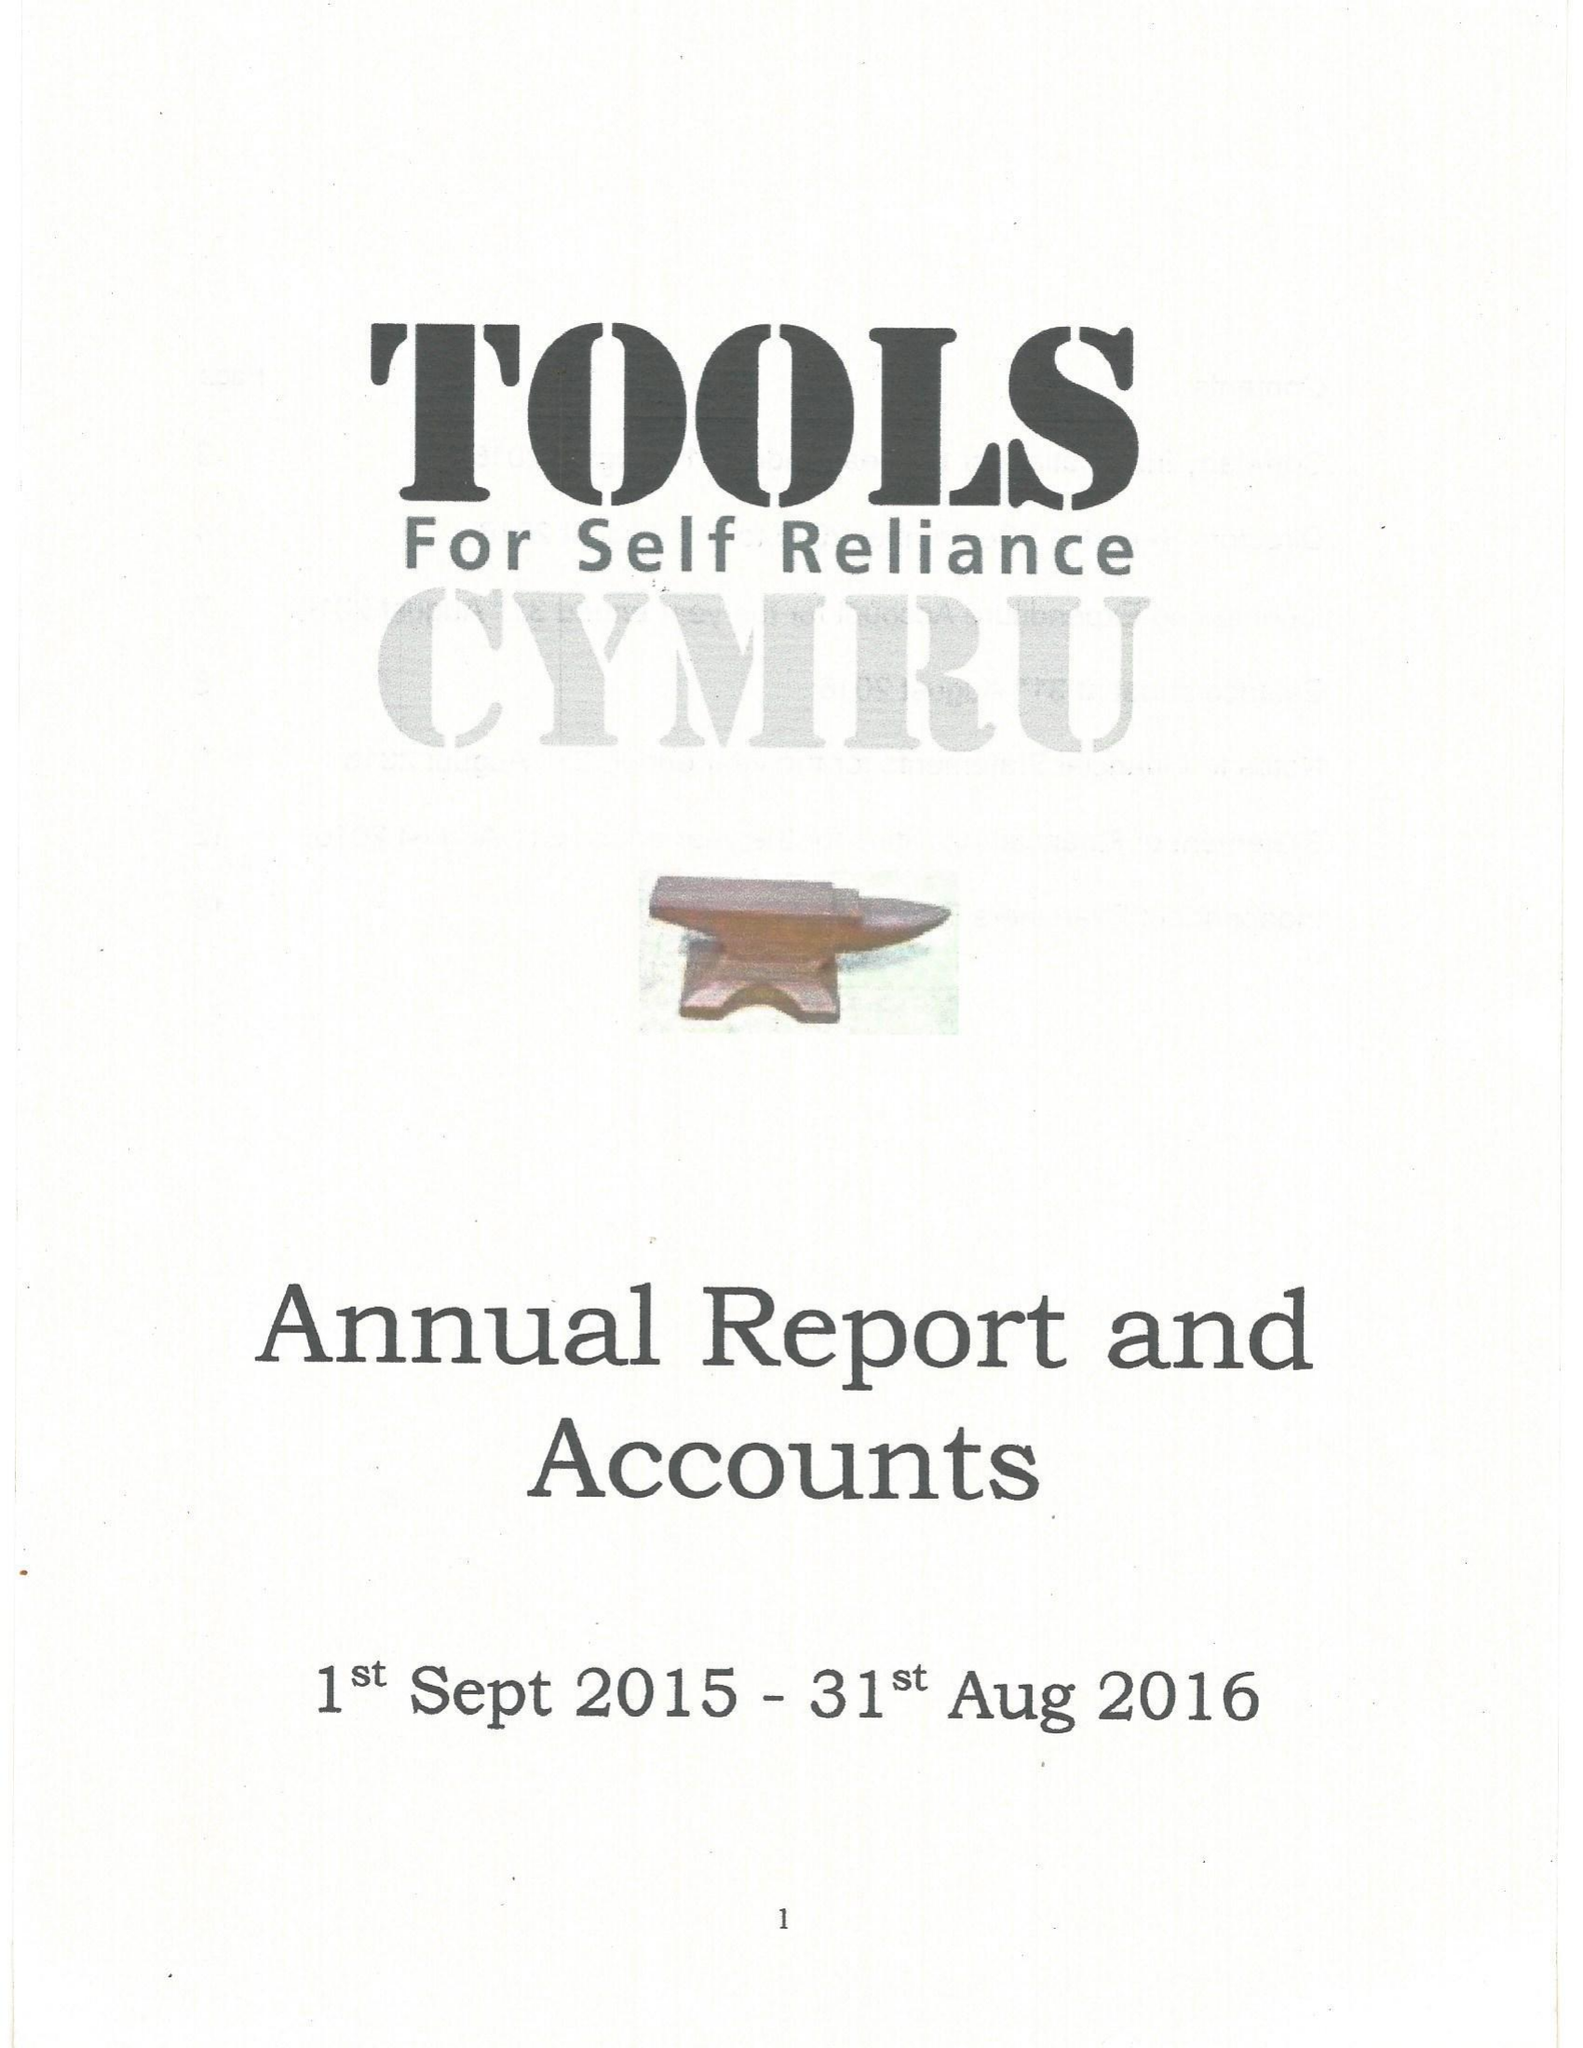What is the value for the report_date?
Answer the question using a single word or phrase. 2016-08-31 